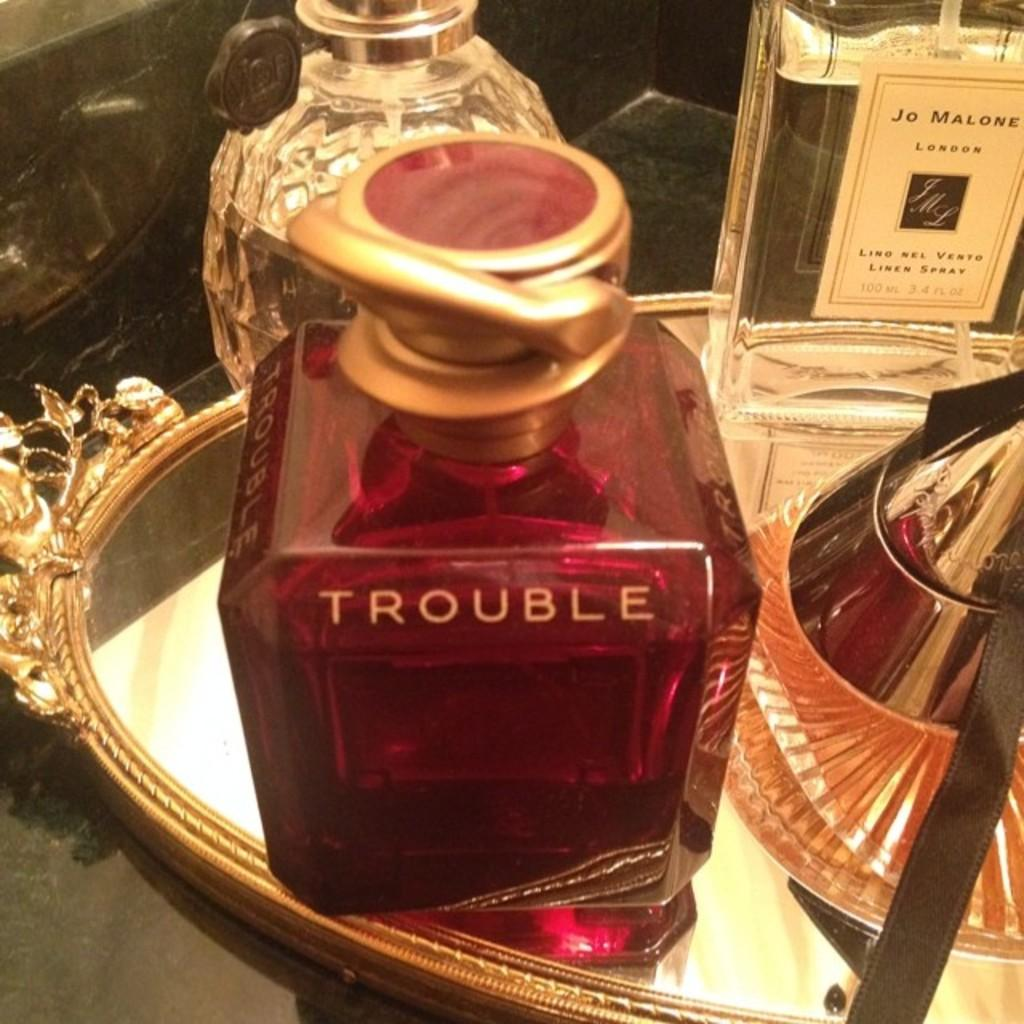<image>
Present a compact description of the photo's key features. Square bottle of TROUBLE on top of a golden plate. 